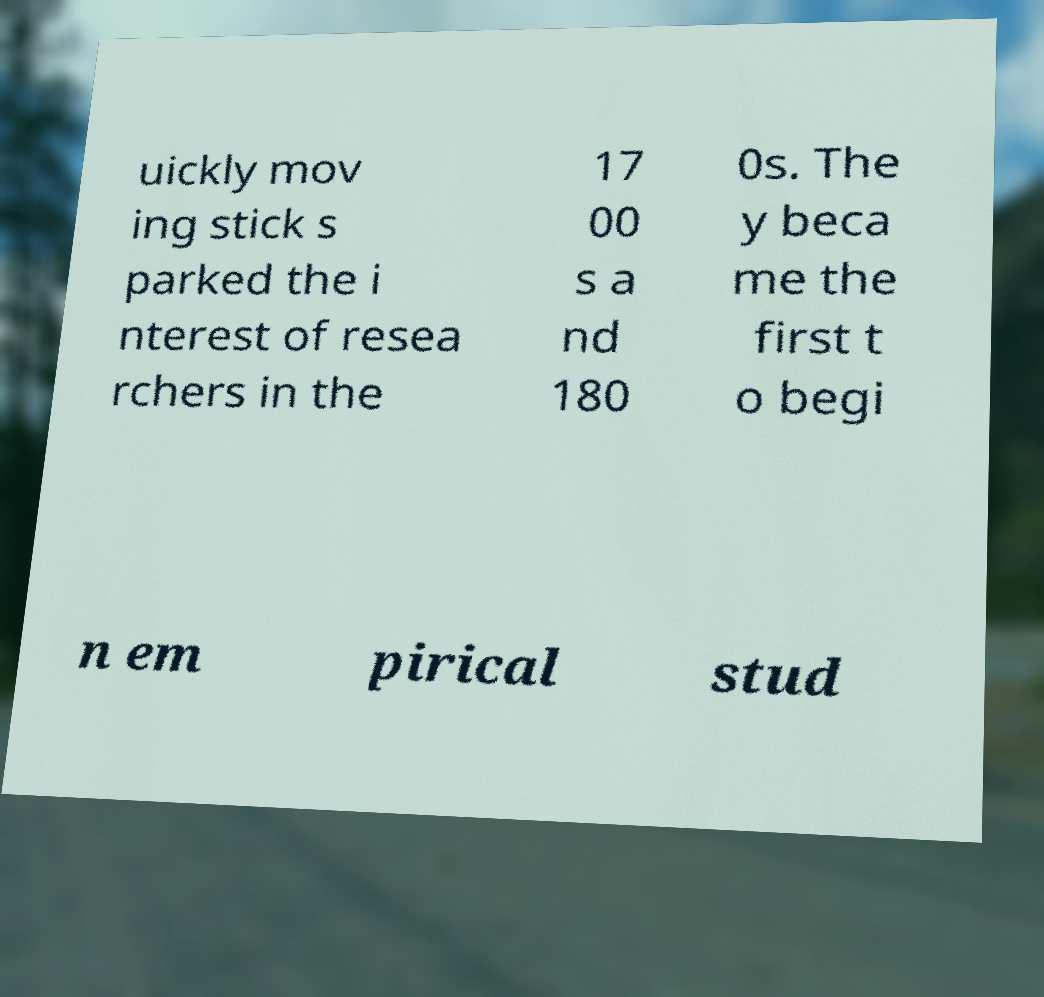Can you accurately transcribe the text from the provided image for me? uickly mov ing stick s parked the i nterest of resea rchers in the 17 00 s a nd 180 0s. The y beca me the first t o begi n em pirical stud 